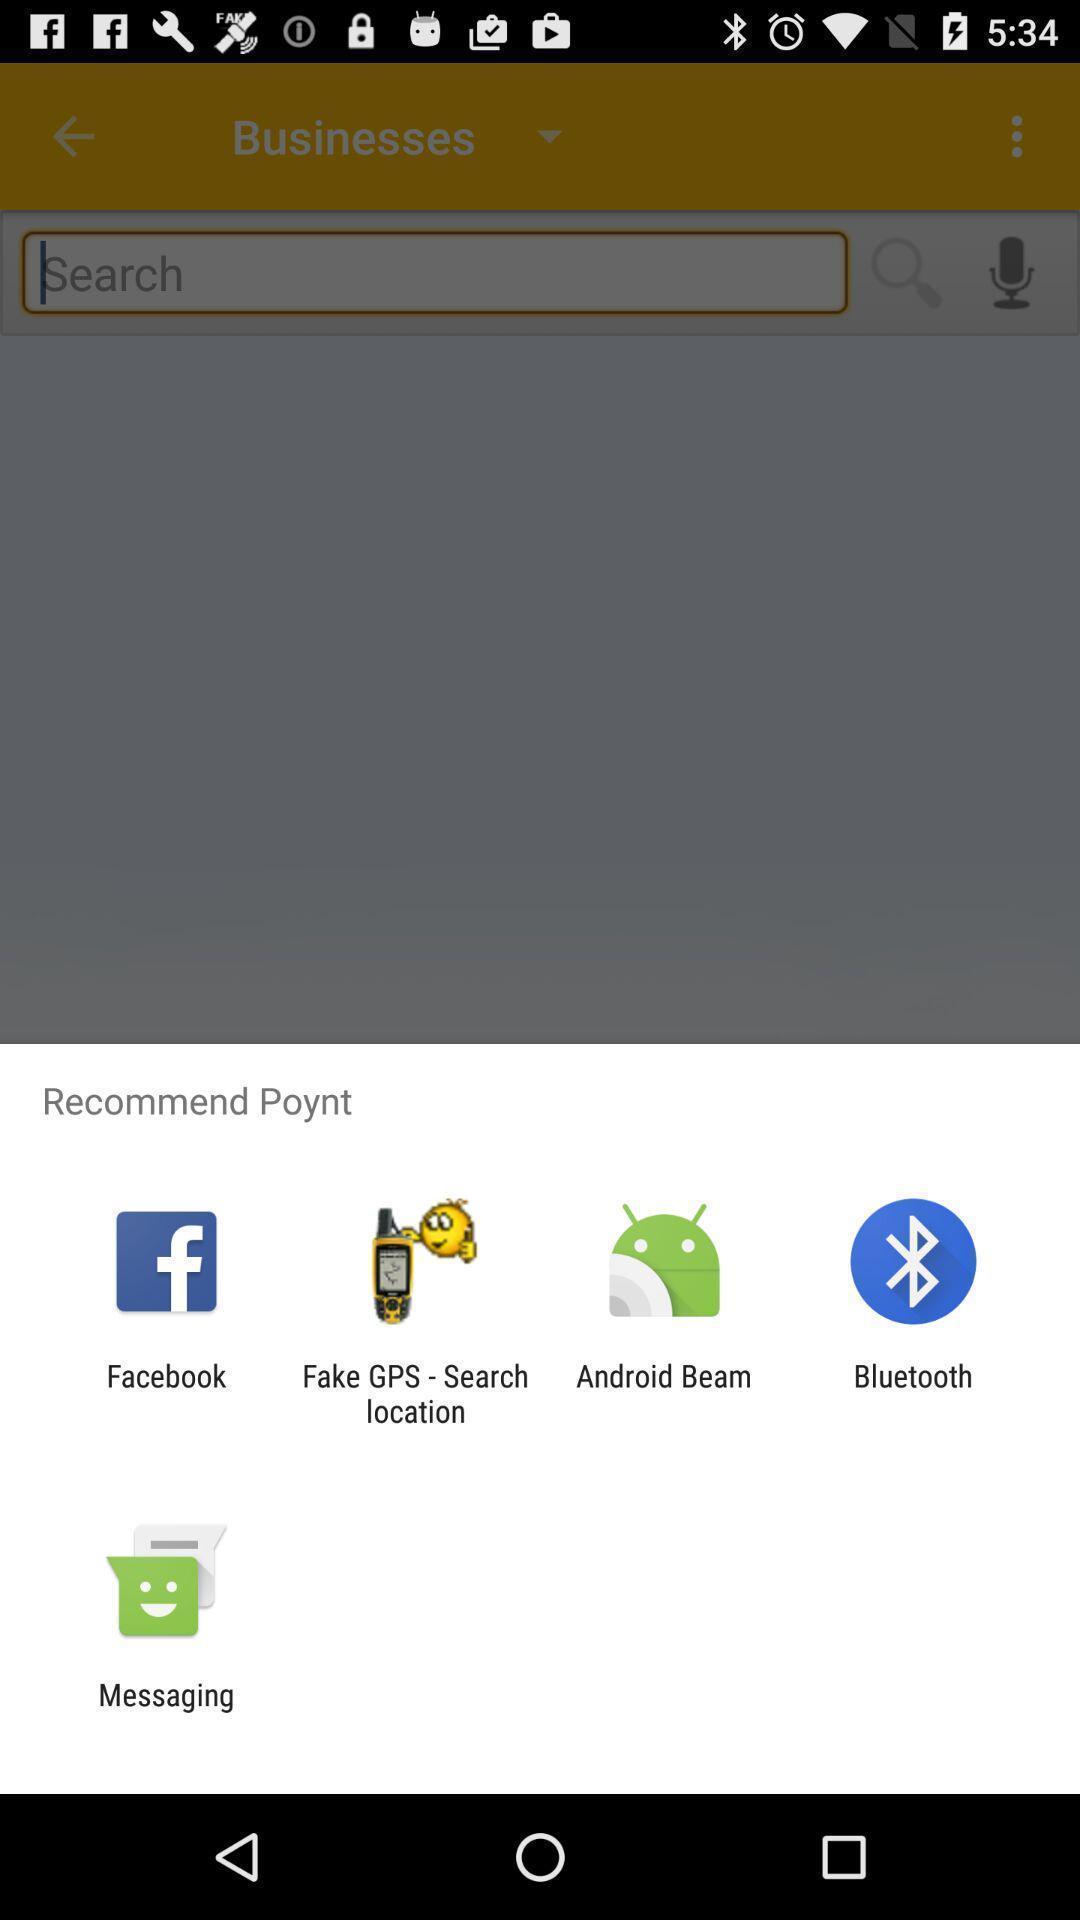Describe the visual elements of this screenshot. Pop up to share via different applications. 